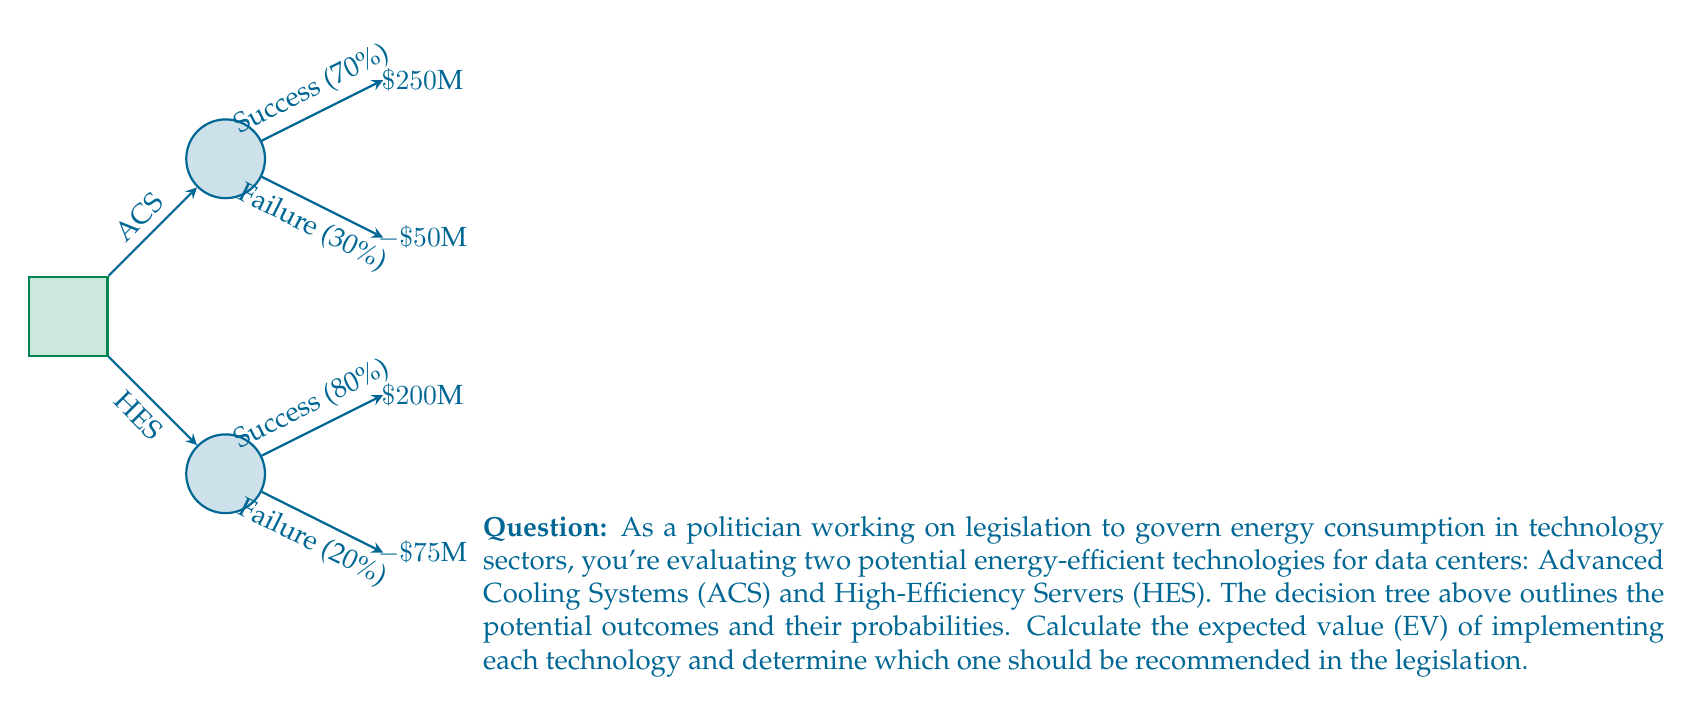Could you help me with this problem? To solve this problem, we need to calculate the expected value (EV) for each technology using the decision tree. Let's go through it step-by-step:

1. Advanced Cooling Systems (ACS):
   - Success probability: 70% (0.7)
   - Failure probability: 30% (0.3)
   - Success outcome: $250M
   - Failure outcome: -$50M

   EV(ACS) = (0.7 × $250M) + (0.3 × (-$50M))
   $$ EV(ACS) = 0.7 \times 250 + 0.3 \times (-50) $$
   $$ EV(ACS) = 175 - 15 = 160 $$
   
   The expected value for ACS is $160M.

2. High-Efficiency Servers (HES):
   - Success probability: 80% (0.8)
   - Failure probability: 20% (0.2)
   - Success outcome: $200M
   - Failure outcome: -$75M

   EV(HES) = (0.8 × $200M) + (0.2 × (-$75M))
   $$ EV(HES) = 0.8 \times 200 + 0.2 \times (-75) $$
   $$ EV(HES) = 160 - 15 = 145 $$
   
   The expected value for HES is $145M.

3. Comparing the two options:
   EV(ACS) = $160M
   EV(HES) = $145M

   Since EV(ACS) > EV(HES), the Advanced Cooling Systems technology has a higher expected value.

Therefore, based on the expected value analysis, the Advanced Cooling Systems (ACS) technology should be recommended in the legislation as it has a higher potential benefit ($160M vs $145M).
Answer: Advanced Cooling Systems (ACS) with EV = $160M 